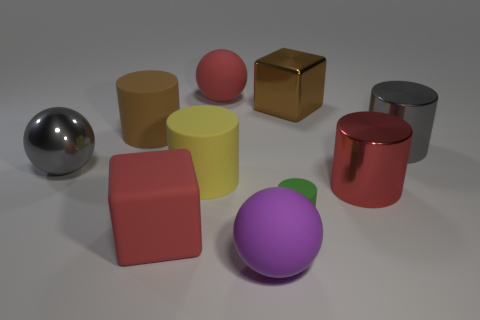There is a large metallic ball; is it the same color as the block that is in front of the big shiny block?
Your answer should be compact. No. What number of green things are either big shiny spheres or rubber blocks?
Make the answer very short. 0. What is the shape of the tiny object?
Your answer should be compact. Cylinder. What number of other things are there of the same shape as the yellow object?
Your answer should be very brief. 4. What is the color of the big metal ball on the left side of the yellow object?
Your answer should be compact. Gray. Do the brown cylinder and the big gray ball have the same material?
Make the answer very short. No. What number of things are either red matte things or large spheres behind the large brown rubber cylinder?
Keep it short and to the point. 2. The ball that is the same color as the matte cube is what size?
Your answer should be compact. Large. What is the shape of the big brown thing that is left of the brown metal block?
Offer a very short reply. Cylinder. There is a big rubber ball behind the big purple object; is its color the same as the large rubber block?
Offer a terse response. Yes. 